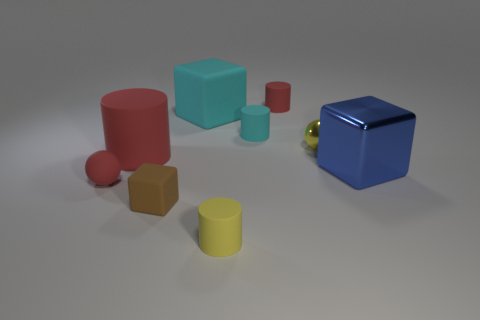Is there a cyan object that has the same shape as the blue object?
Ensure brevity in your answer.  Yes. How many small rubber cubes are there?
Your answer should be very brief. 1. The tiny cyan object is what shape?
Make the answer very short. Cylinder. What number of yellow matte cubes have the same size as the cyan rubber cube?
Give a very brief answer. 0. Does the yellow shiny object have the same shape as the large red rubber thing?
Offer a terse response. No. There is a tiny matte object that is in front of the cube in front of the tiny red matte ball; what color is it?
Provide a short and direct response. Yellow. There is a cube that is both to the left of the metallic block and right of the brown thing; what size is it?
Provide a succinct answer. Large. Are there any other things that have the same color as the rubber ball?
Your answer should be very brief. Yes. The tiny cyan object that is made of the same material as the large cylinder is what shape?
Provide a succinct answer. Cylinder. There is a tiny yellow metal object; is its shape the same as the small thing that is to the left of the small brown block?
Give a very brief answer. Yes. 